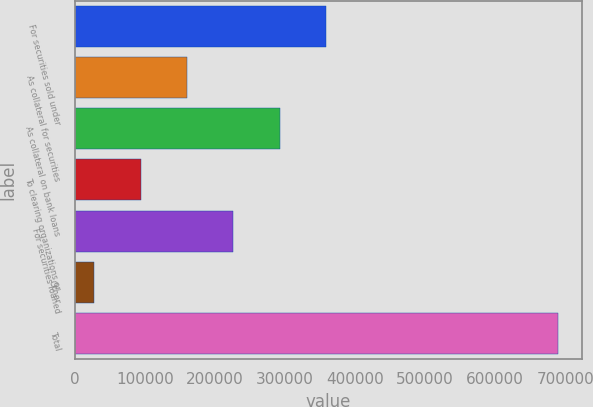<chart> <loc_0><loc_0><loc_500><loc_500><bar_chart><fcel>For securities sold under<fcel>As collateral for securities<fcel>As collateral on bank loans<fcel>To clearing organizations or<fcel>For securities loaned<fcel>Other<fcel>Total<nl><fcel>358584<fcel>160142<fcel>292437<fcel>93994.4<fcel>226289<fcel>27847<fcel>689321<nl></chart> 